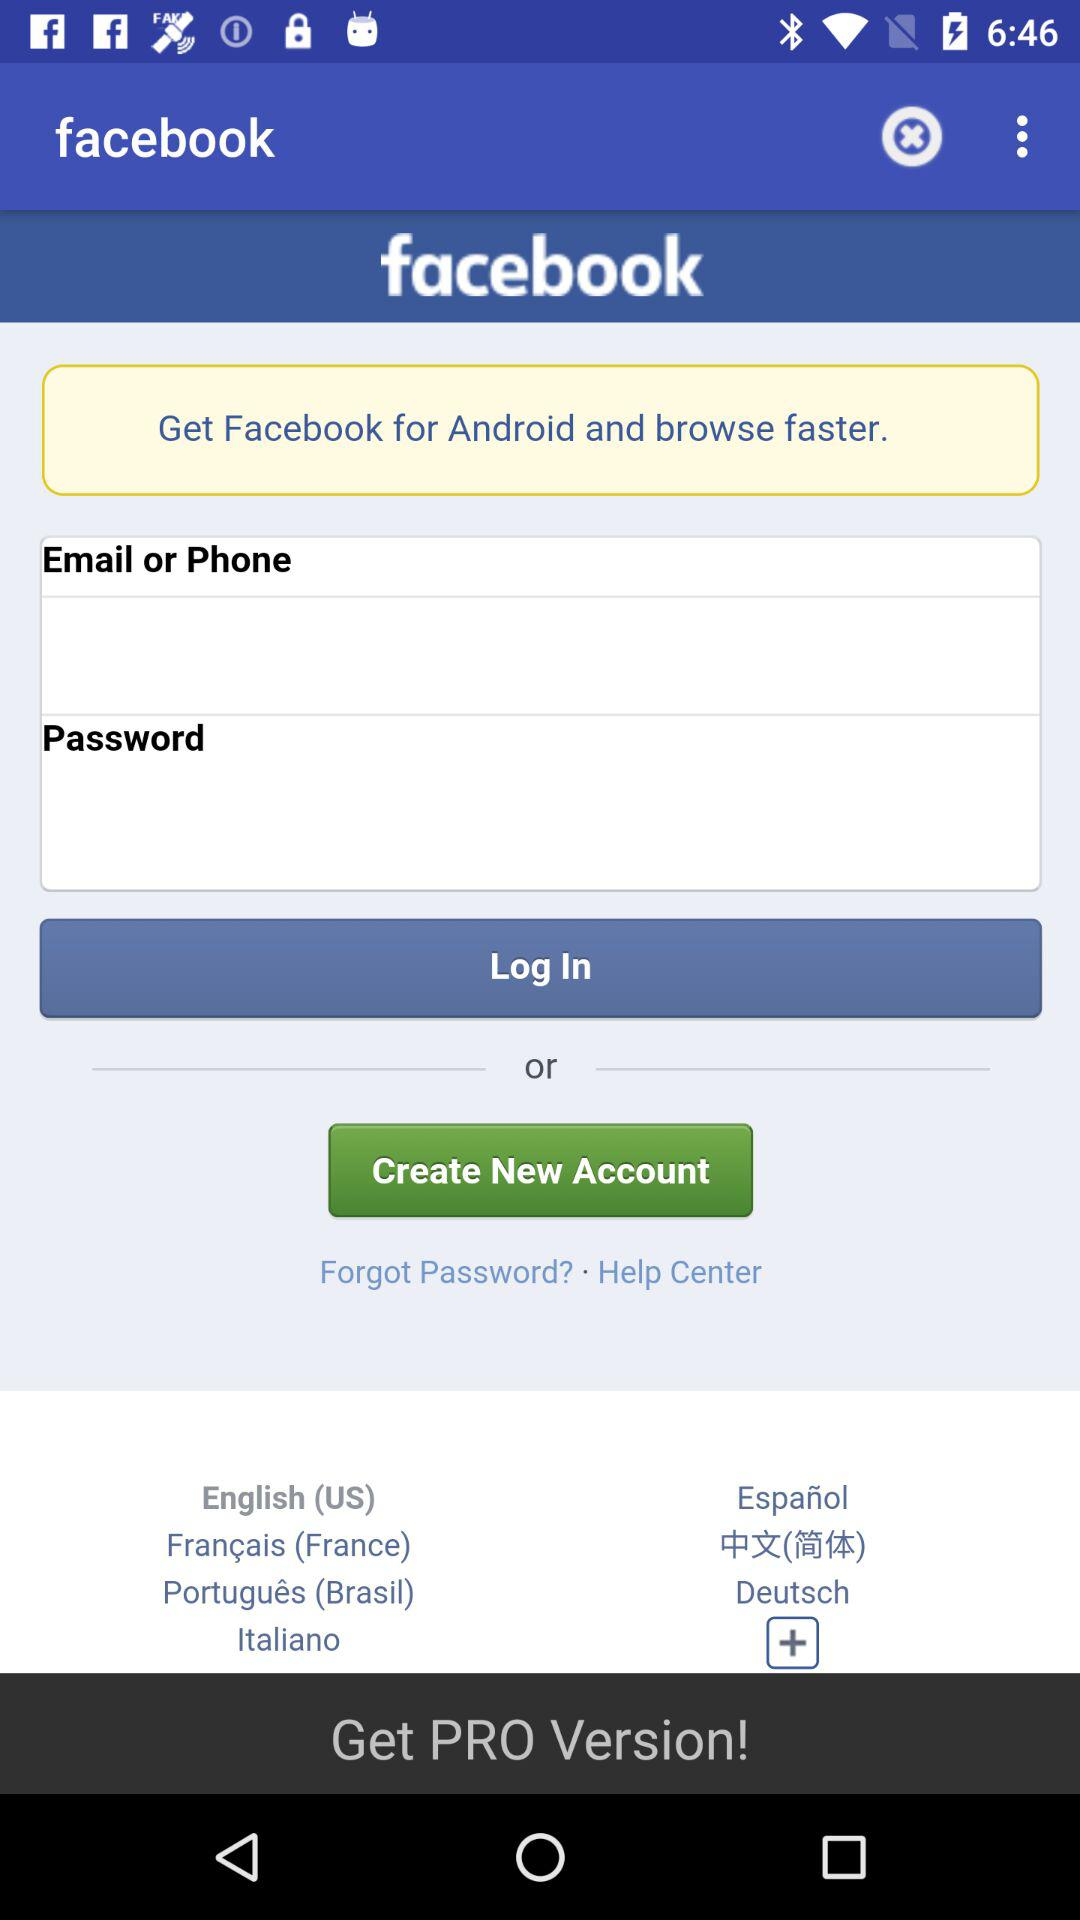How many input fields are there for logging in?
Answer the question using a single word or phrase. 2 